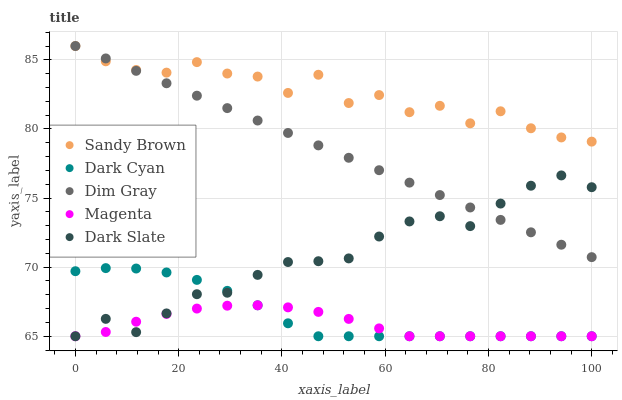Does Magenta have the minimum area under the curve?
Answer yes or no. Yes. Does Sandy Brown have the maximum area under the curve?
Answer yes or no. Yes. Does Dark Slate have the minimum area under the curve?
Answer yes or no. No. Does Dark Slate have the maximum area under the curve?
Answer yes or no. No. Is Dim Gray the smoothest?
Answer yes or no. Yes. Is Sandy Brown the roughest?
Answer yes or no. Yes. Is Dark Slate the smoothest?
Answer yes or no. No. Is Dark Slate the roughest?
Answer yes or no. No. Does Dark Cyan have the lowest value?
Answer yes or no. Yes. Does Dim Gray have the lowest value?
Answer yes or no. No. Does Sandy Brown have the highest value?
Answer yes or no. Yes. Does Dark Slate have the highest value?
Answer yes or no. No. Is Dark Slate less than Sandy Brown?
Answer yes or no. Yes. Is Sandy Brown greater than Magenta?
Answer yes or no. Yes. Does Dark Cyan intersect Magenta?
Answer yes or no. Yes. Is Dark Cyan less than Magenta?
Answer yes or no. No. Is Dark Cyan greater than Magenta?
Answer yes or no. No. Does Dark Slate intersect Sandy Brown?
Answer yes or no. No. 